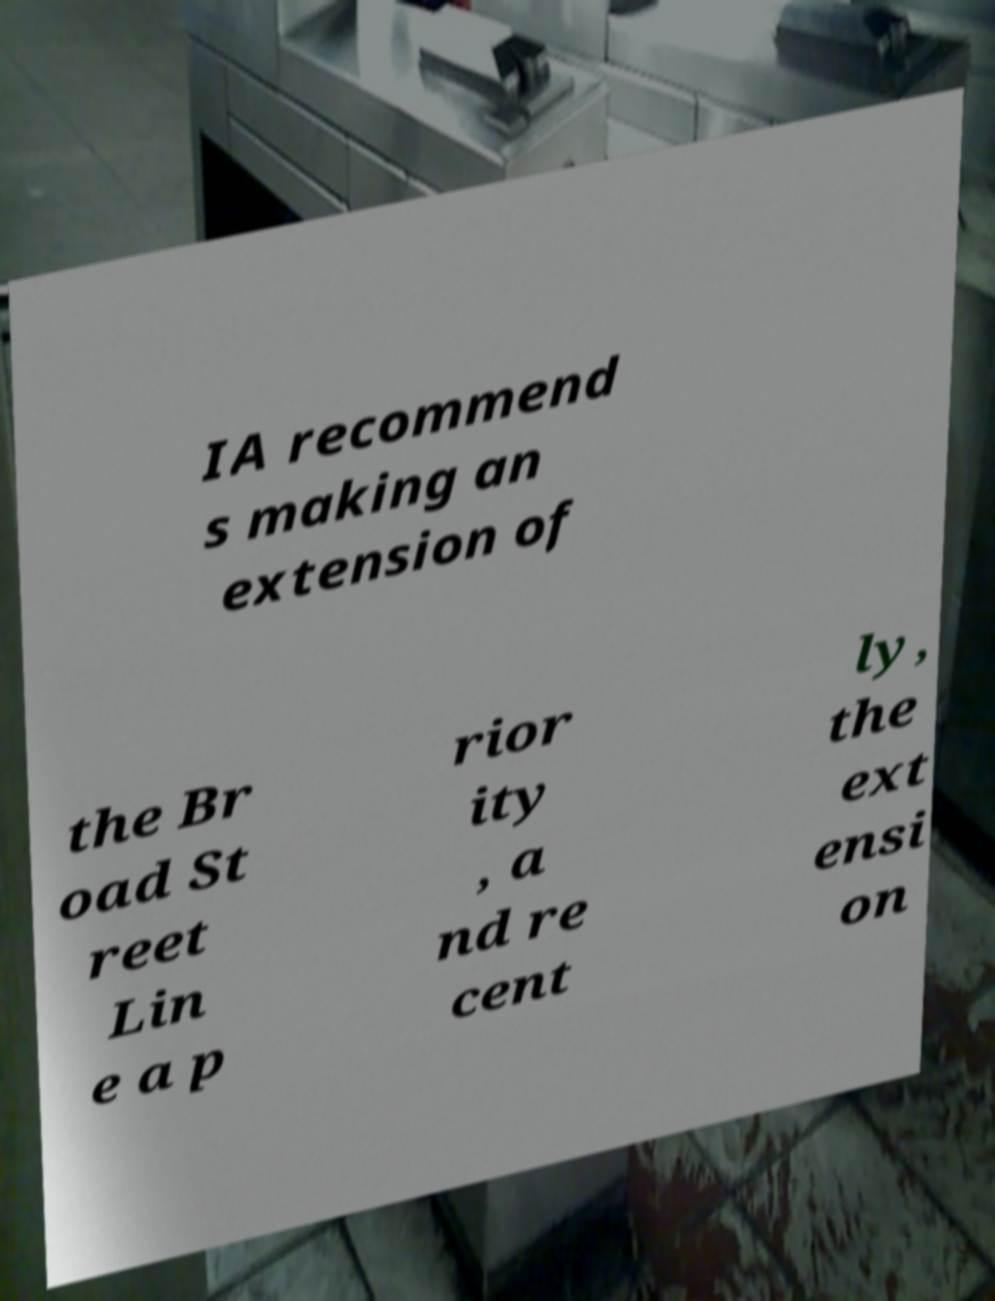What messages or text are displayed in this image? I need them in a readable, typed format. IA recommend s making an extension of the Br oad St reet Lin e a p rior ity , a nd re cent ly, the ext ensi on 